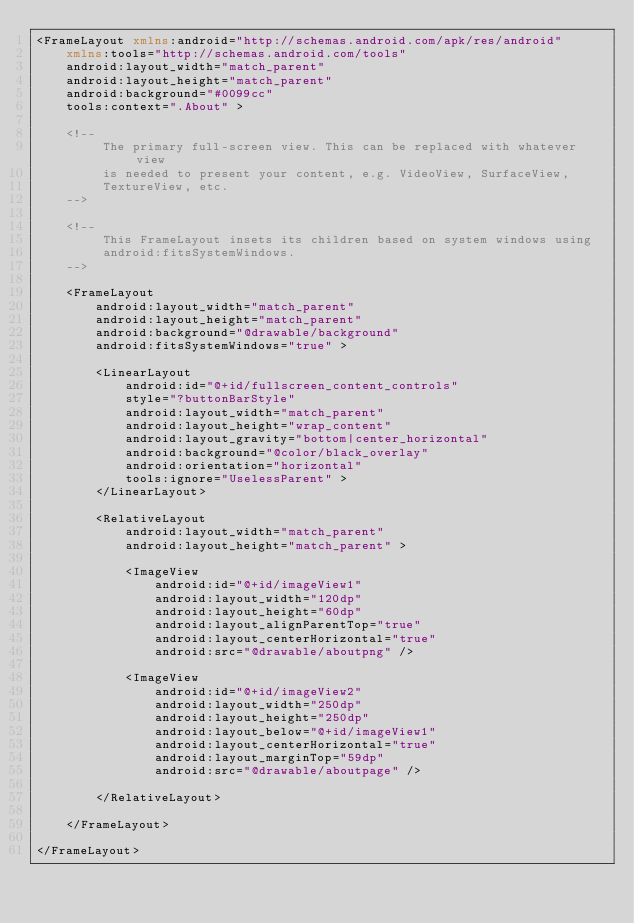Convert code to text. <code><loc_0><loc_0><loc_500><loc_500><_XML_><FrameLayout xmlns:android="http://schemas.android.com/apk/res/android"
    xmlns:tools="http://schemas.android.com/tools"
    android:layout_width="match_parent"
    android:layout_height="match_parent"
    android:background="#0099cc"
    tools:context=".About" >

    <!--
         The primary full-screen view. This can be replaced with whatever view
         is needed to present your content, e.g. VideoView, SurfaceView,
         TextureView, etc.
    -->

    <!--
         This FrameLayout insets its children based on system windows using
         android:fitsSystemWindows.
    -->

    <FrameLayout
        android:layout_width="match_parent"
        android:layout_height="match_parent"
        android:background="@drawable/background"
        android:fitsSystemWindows="true" >

        <LinearLayout
            android:id="@+id/fullscreen_content_controls"
            style="?buttonBarStyle"
            android:layout_width="match_parent"
            android:layout_height="wrap_content"
            android:layout_gravity="bottom|center_horizontal"
            android:background="@color/black_overlay"
            android:orientation="horizontal"
            tools:ignore="UselessParent" >
        </LinearLayout>

        <RelativeLayout
            android:layout_width="match_parent"
            android:layout_height="match_parent" >

            <ImageView
                android:id="@+id/imageView1"
                android:layout_width="120dp"
                android:layout_height="60dp"
                android:layout_alignParentTop="true"
                android:layout_centerHorizontal="true"
                android:src="@drawable/aboutpng" />

            <ImageView
                android:id="@+id/imageView2"
                android:layout_width="250dp"
                android:layout_height="250dp"
                android:layout_below="@+id/imageView1"
                android:layout_centerHorizontal="true"
                android:layout_marginTop="59dp"
                android:src="@drawable/aboutpage" />
			
        </RelativeLayout>

    </FrameLayout>

</FrameLayout></code> 